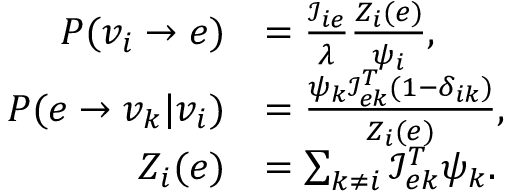<formula> <loc_0><loc_0><loc_500><loc_500>\begin{array} { r l } { P ( v _ { i } \rightarrow e ) } & { = \frac { \mathcal { I } _ { i e } } { \lambda } \frac { Z _ { i } ( e ) } { \psi _ { i } } , } \\ { P ( e \rightarrow v _ { k } | v _ { i } ) } & { = \frac { \psi _ { k } \mathcal { I } _ { e k } ^ { T } ( 1 - \delta _ { i k } ) } { Z _ { i } ( e ) } , } \\ { Z _ { i } ( e ) } & { = \sum _ { k \neq i } \mathcal { I } _ { e k } ^ { T } \psi _ { k } . } \end{array}</formula> 